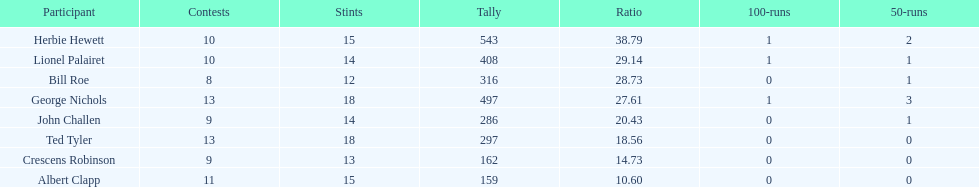How many players played more than 10 matches? 3. 